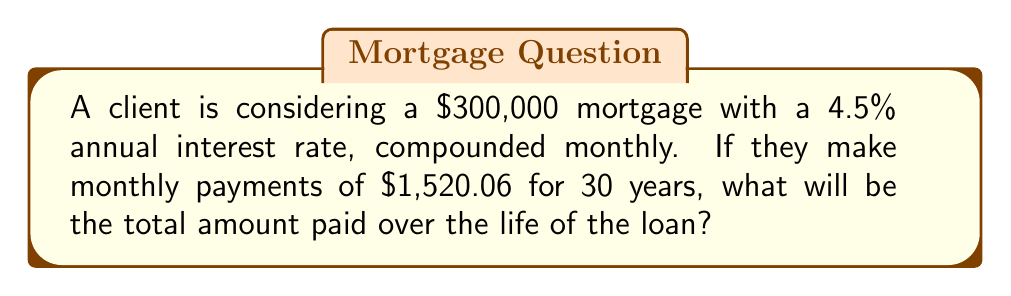Could you help me with this problem? To solve this problem, we'll follow these steps:

1. Calculate the number of payments:
   $n = 30 \text{ years} \times 12 \text{ months/year} = 360 \text{ payments}$

2. Calculate the monthly interest rate:
   $r = \frac{4.5\%}{12} = 0.375\% = 0.00375$

3. Use the compound interest formula for monthly payments:
   $$A = P \times \frac{r(1+r)^n}{(1+r)^n - 1}$$
   Where:
   $A$ = monthly payment
   $P$ = principal (loan amount)
   $r$ = monthly interest rate
   $n$ = total number of payments

4. We know $A$, so we'll verify our numbers:
   $$1520.06 \approx 300000 \times \frac{0.00375(1+0.00375)^{360}}{(1+0.00375)^{360} - 1}$$

5. Calculate the total amount paid:
   $\text{Total Paid} = \text{Monthly Payment} \times \text{Number of Payments}$
   $\text{Total Paid} = 1520.06 \times 360 = 547,221.60$
Answer: $547,221.60 